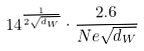Convert formula to latex. <formula><loc_0><loc_0><loc_500><loc_500>1 4 ^ { \frac { 1 } { 2 \sqrt { d _ { W } } } } \cdot \frac { 2 . 6 } { N e \sqrt { d _ { W } } }</formula> 